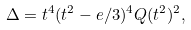Convert formula to latex. <formula><loc_0><loc_0><loc_500><loc_500>\Delta = t ^ { 4 } ( t ^ { 2 } - e / 3 ) ^ { 4 } Q ( t ^ { 2 } ) ^ { 2 } ,</formula> 